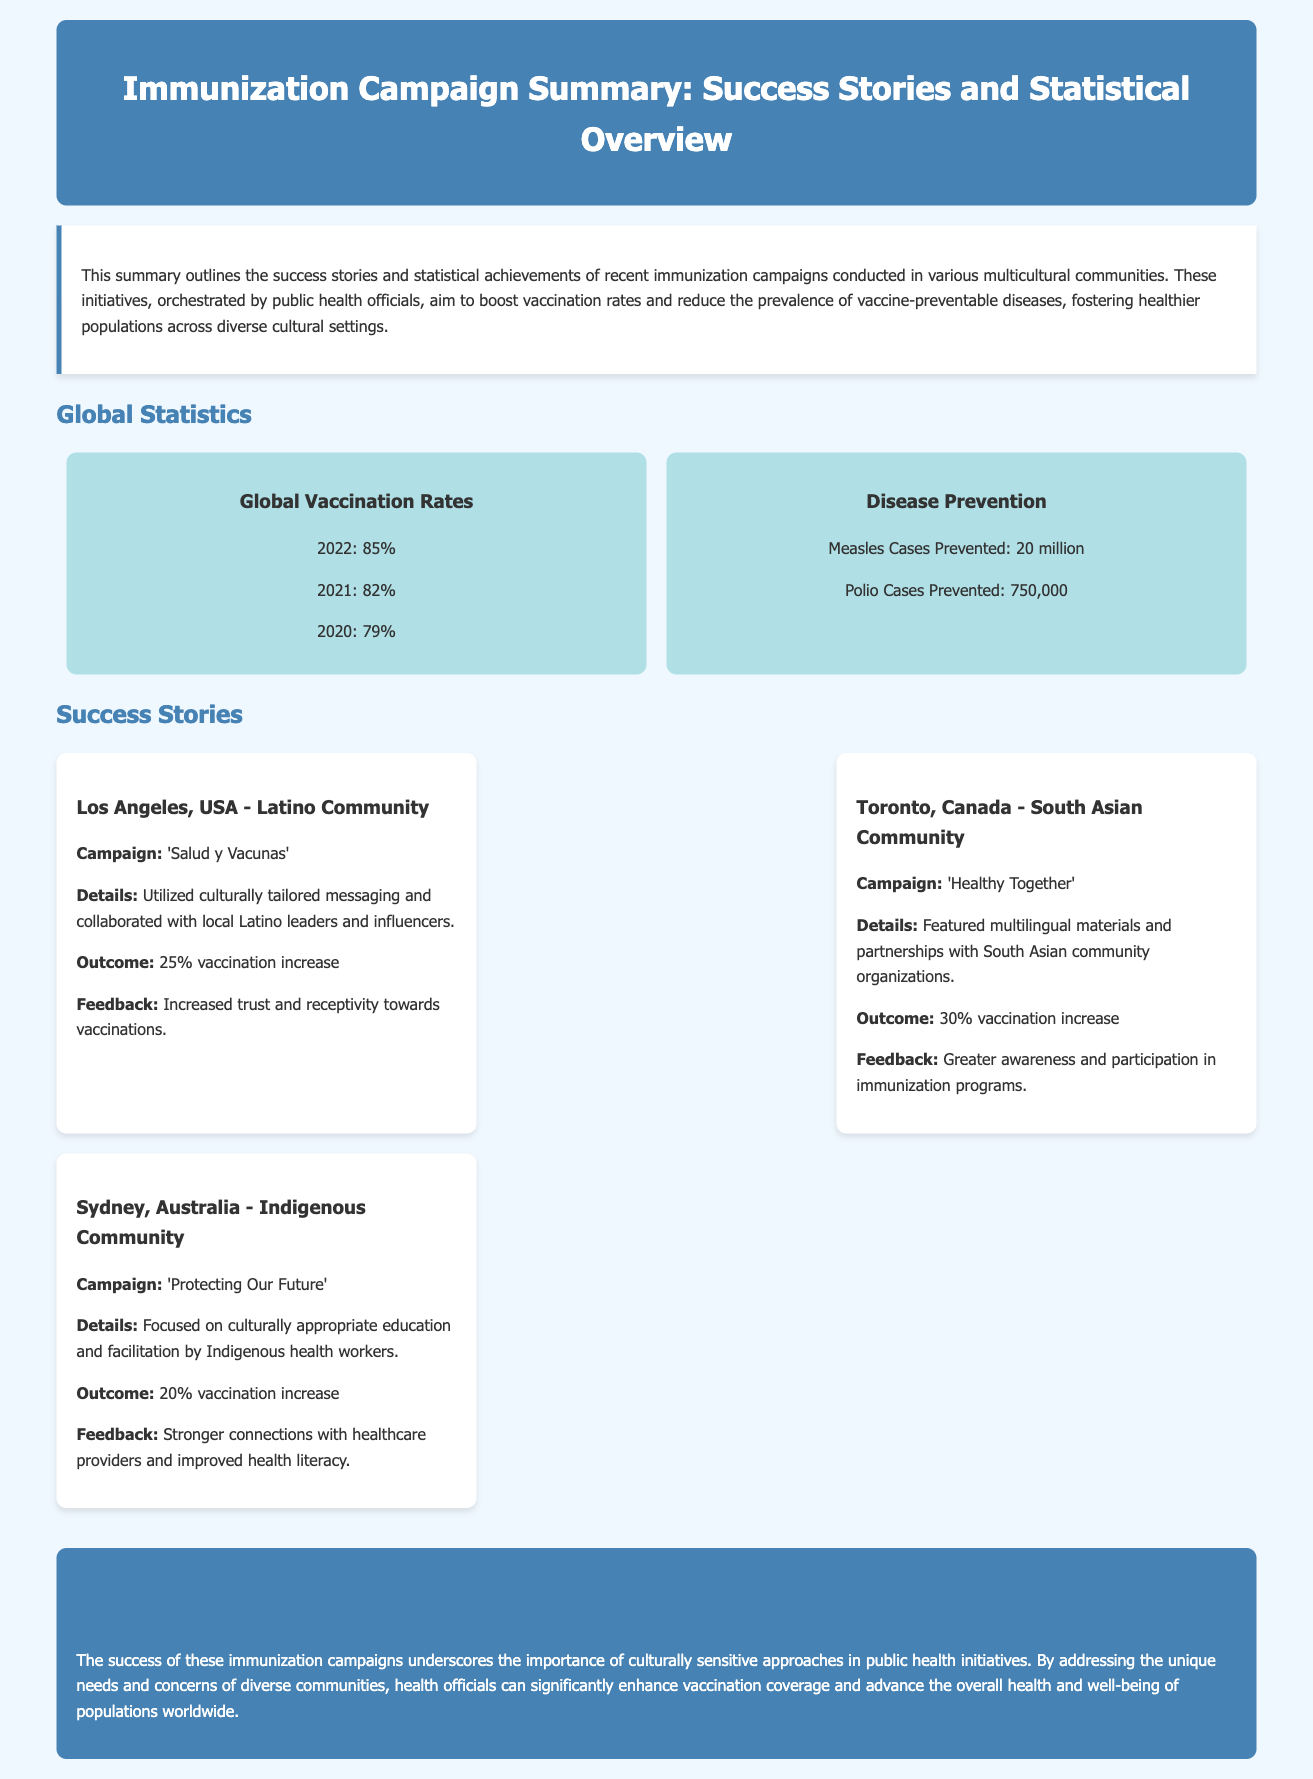What was the global vaccination rate in 2022? The global vaccination rate for 2022 is specified in the statistics section of the document.
Answer: 85% How many measles cases were prevented globally? The document states the number of measles cases prevented as part of the disease prevention statistics.
Answer: 20 million Which community was targeted in Los Angeles, USA? The document describes the target community as part of the specific success story from Los Angeles, USA.
Answer: Latino Community What was the outcome of the 'Healthy Together' campaign in Toronto? The outcome of the Toronto campaign is mentioned in the success stories section, indicating a percentage increase in vaccinations.
Answer: 30% vaccination increase What cultural approach was emphasized in the Sydney campaign? The document highlights the culturally appropriate education as the central theme of the Sydney campaign.
Answer: Culturally appropriate education How much did vaccination rates increase in the Indigenous Community campaign? The increase in vaccination rates for the Indigenous Community campaign is detailed in the success stories section.
Answer: 20% vaccination increase What type of materials were used in the Toronto campaign? The document notes the use of multilingual materials in the campaign conducted in Toronto.
Answer: Multilingual materials What was a notable feedback from the Los Angeles campaign? The feedback received from the Latino Community campaign is stated in the success stories section.
Answer: Increased trust and receptivity towards vaccinations What is the main theme of the conclusion? The conclusion section summarizes the overarching message regarding cultural sensitivity in public health initiatives.
Answer: Culturally sensitive approaches 